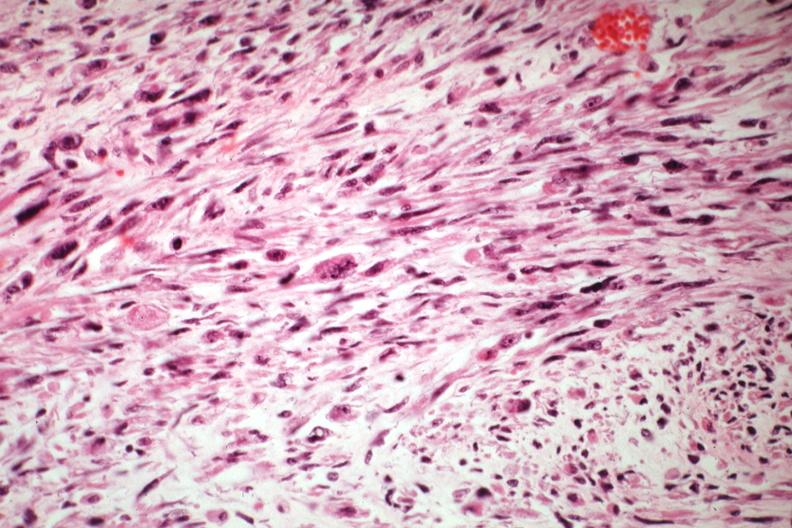what is present?
Answer the question using a single word or phrase. Female reproductive 